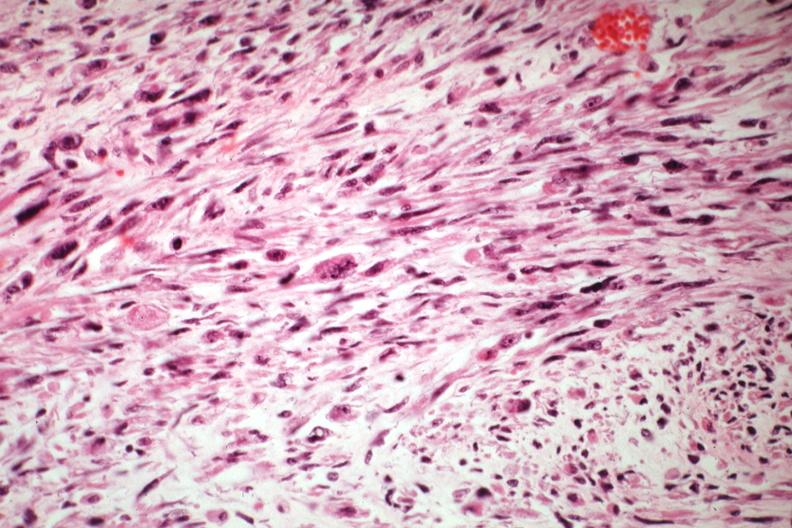what is present?
Answer the question using a single word or phrase. Female reproductive 